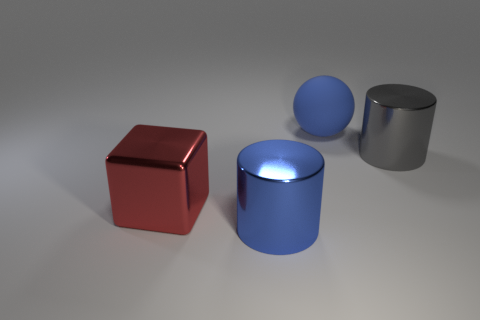Is there anything else that has the same material as the big blue sphere?
Provide a succinct answer. No. What number of other blue objects have the same shape as the blue rubber object?
Offer a very short reply. 0. What number of large cylinders are to the right of the red thing?
Your response must be concise. 2. Do the metal cylinder on the left side of the big rubber object and the cube have the same color?
Offer a terse response. No. What number of matte objects are the same size as the red cube?
Provide a short and direct response. 1. There is a blue object that is the same material as the gray cylinder; what is its shape?
Provide a succinct answer. Cylinder. Are there any big things of the same color as the large rubber ball?
Offer a terse response. Yes. What material is the large sphere?
Your answer should be very brief. Rubber. How many things are large gray things or green cubes?
Provide a succinct answer. 1. What size is the thing that is in front of the large red metal cube?
Your response must be concise. Large. 